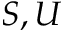<formula> <loc_0><loc_0><loc_500><loc_500>S , U</formula> 